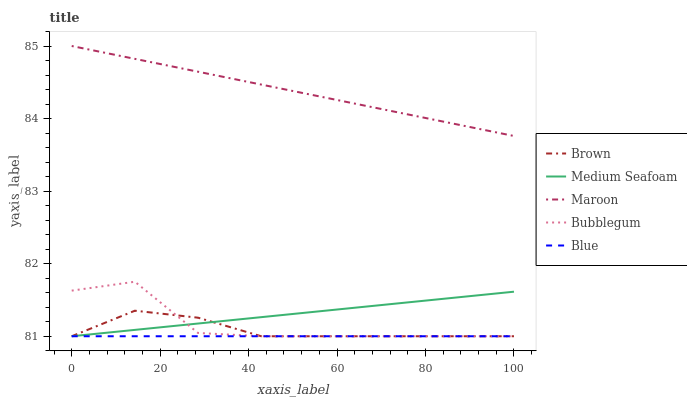Does Blue have the minimum area under the curve?
Answer yes or no. Yes. Does Maroon have the maximum area under the curve?
Answer yes or no. Yes. Does Brown have the minimum area under the curve?
Answer yes or no. No. Does Brown have the maximum area under the curve?
Answer yes or no. No. Is Blue the smoothest?
Answer yes or no. Yes. Is Bubblegum the roughest?
Answer yes or no. Yes. Is Brown the smoothest?
Answer yes or no. No. Is Brown the roughest?
Answer yes or no. No. Does Maroon have the lowest value?
Answer yes or no. No. Does Maroon have the highest value?
Answer yes or no. Yes. Does Brown have the highest value?
Answer yes or no. No. Is Bubblegum less than Maroon?
Answer yes or no. Yes. Is Maroon greater than Brown?
Answer yes or no. Yes. Does Bubblegum intersect Maroon?
Answer yes or no. No. 